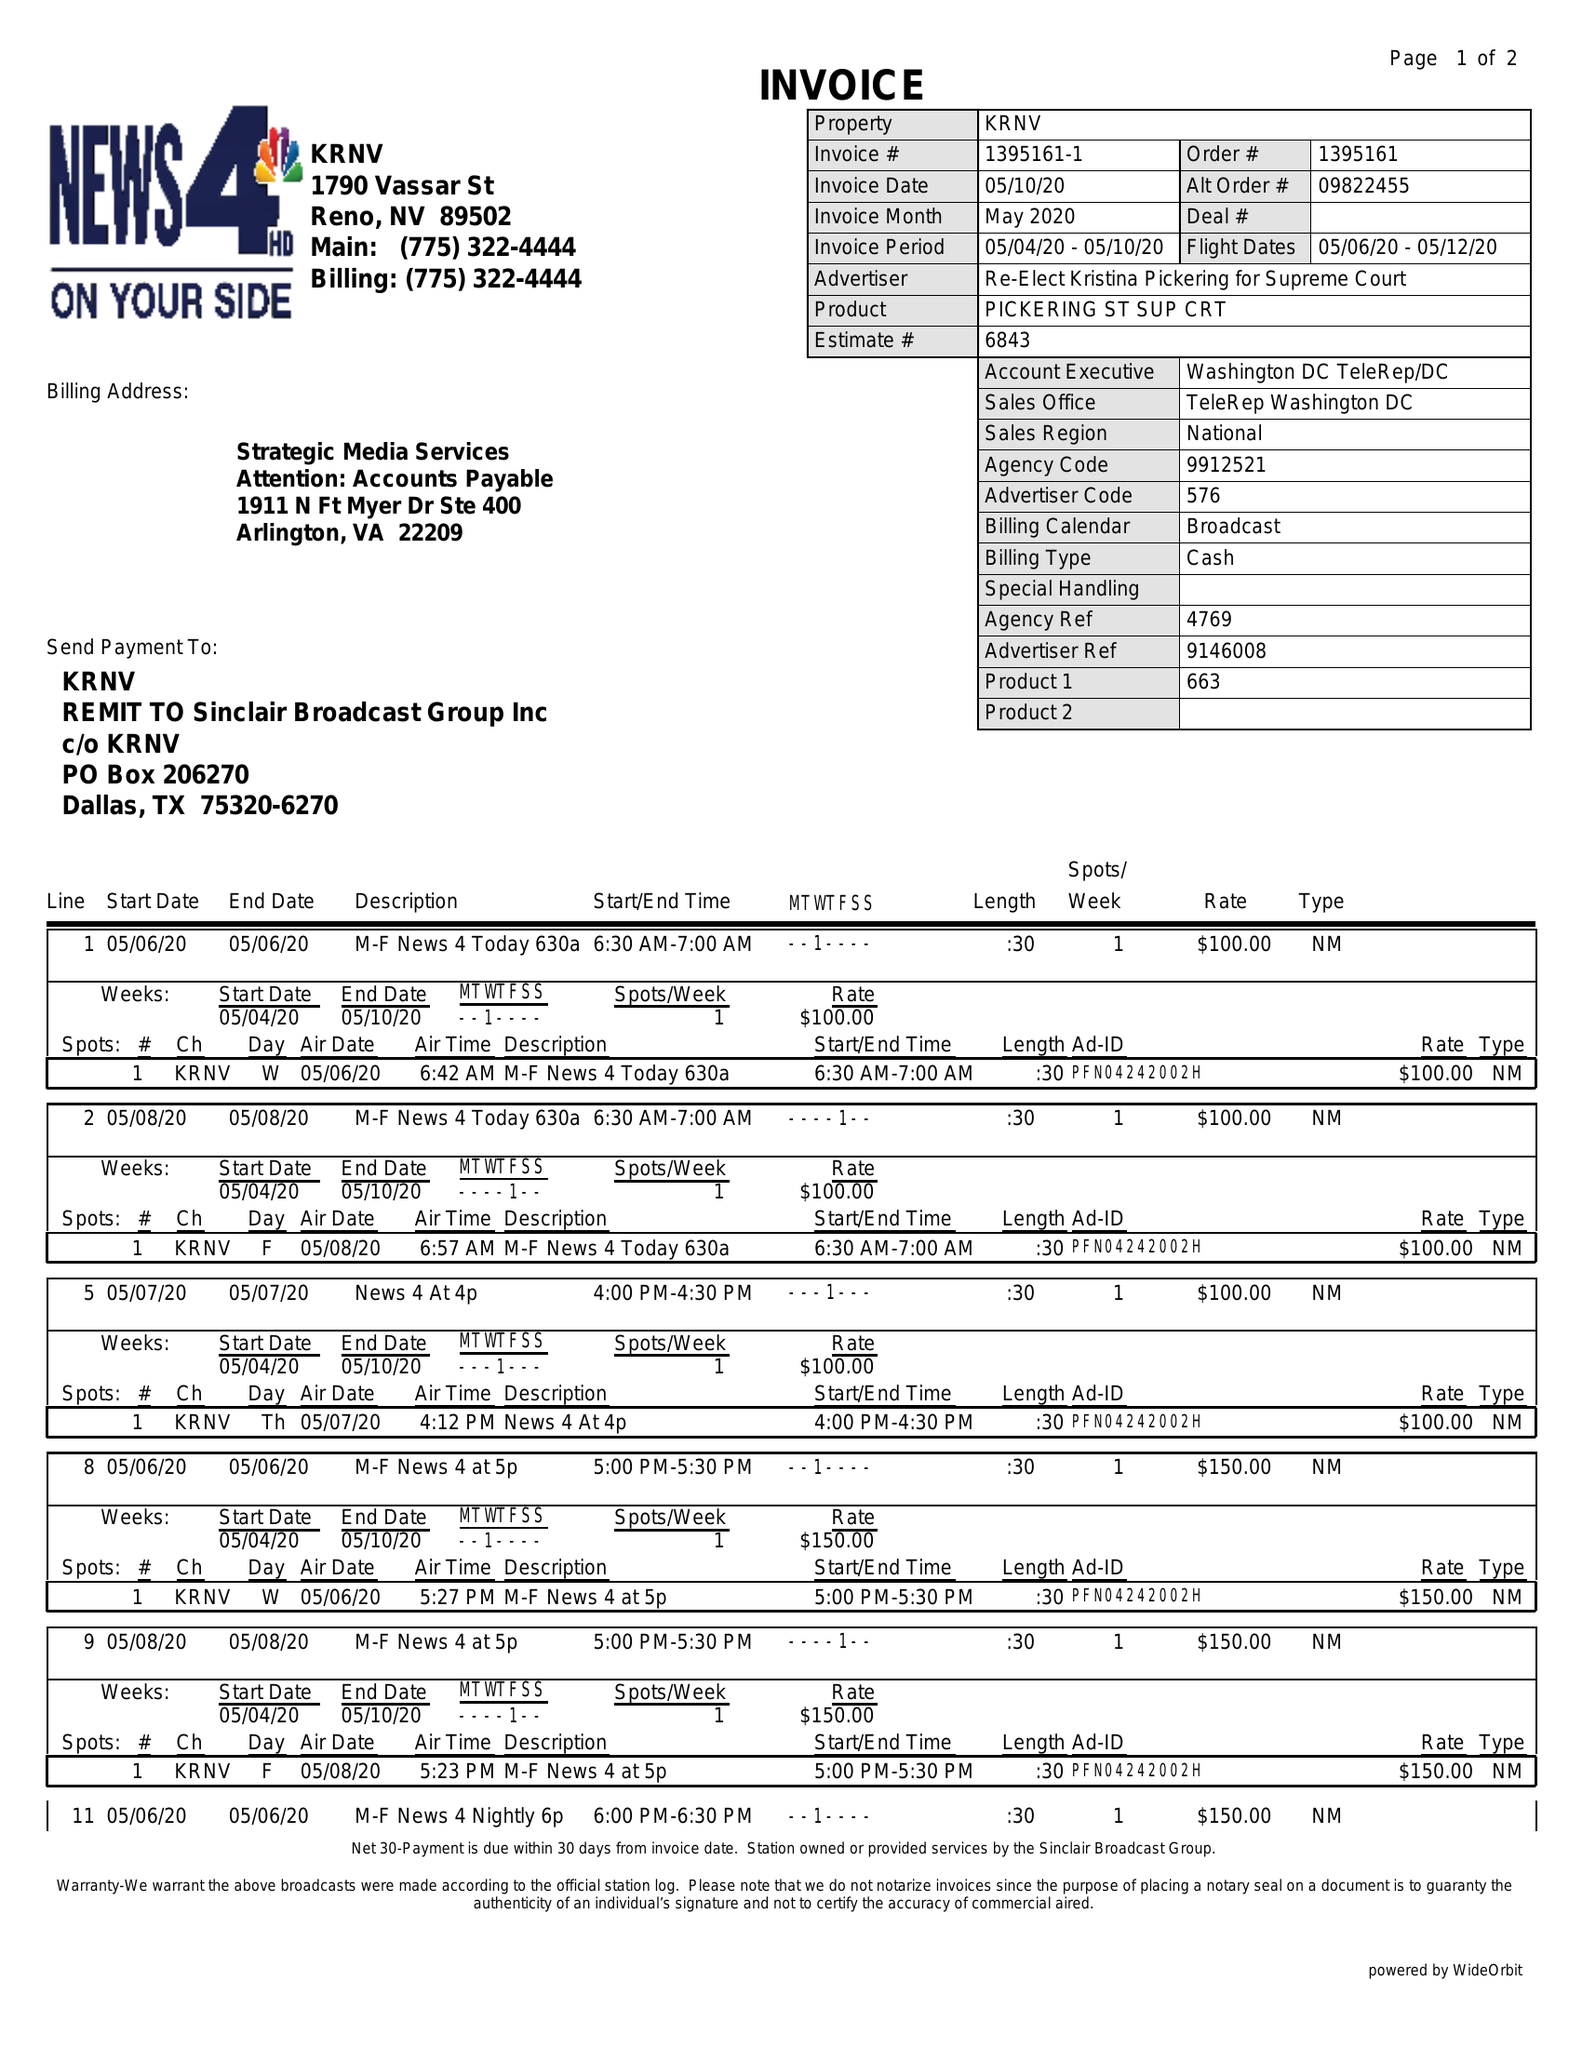What is the value for the gross_amount?
Answer the question using a single word or phrase. 1300.00 